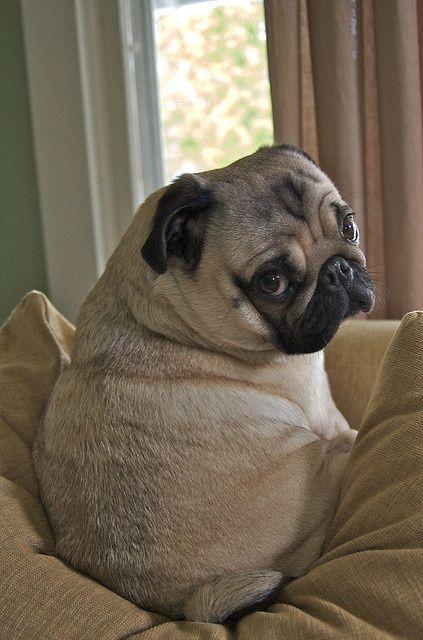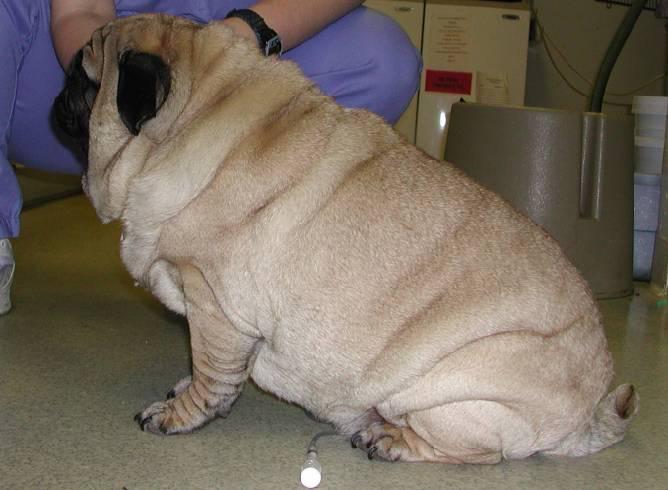The first image is the image on the left, the second image is the image on the right. Assess this claim about the two images: "One dog has its front paws off the ground.". Correct or not? Answer yes or no. No. The first image is the image on the left, the second image is the image on the right. Assess this claim about the two images: "Each image shows one fat beige pug in a sitting pose, and no pugs are wearing outfits.". Correct or not? Answer yes or no. Yes. 